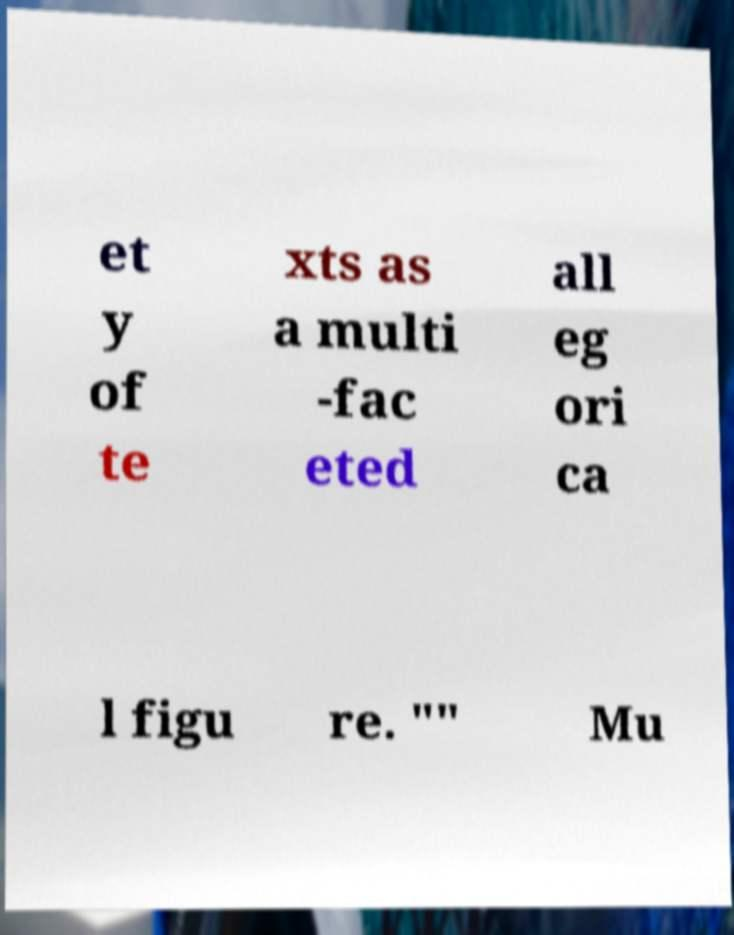Could you assist in decoding the text presented in this image and type it out clearly? et y of te xts as a multi -fac eted all eg ori ca l figu re. "" Mu 